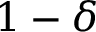Convert formula to latex. <formula><loc_0><loc_0><loc_500><loc_500>1 - \delta</formula> 